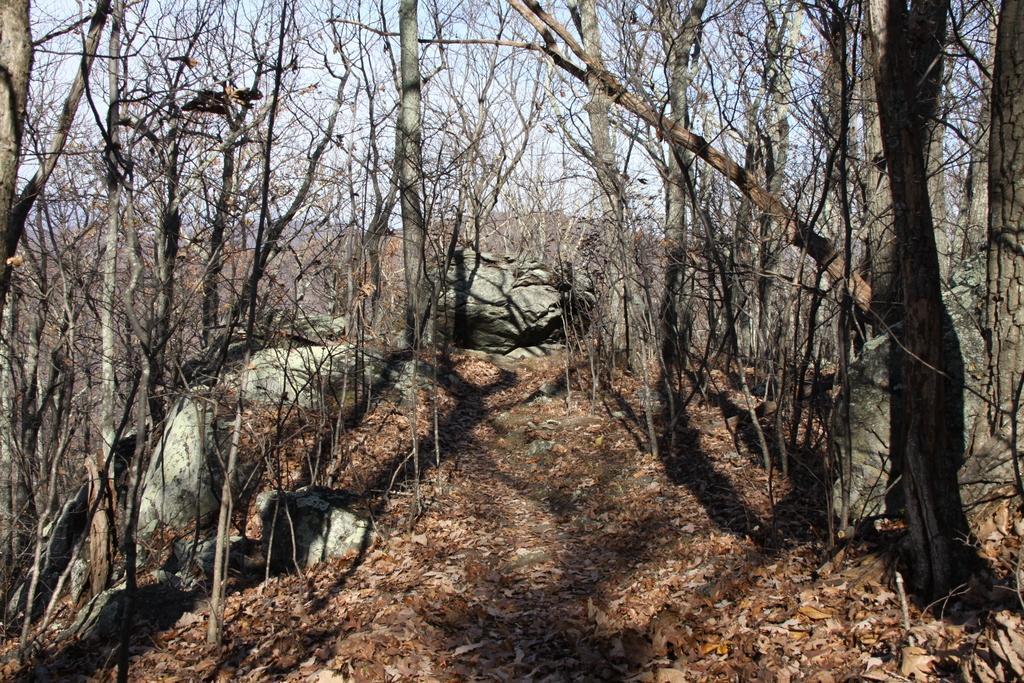In one or two sentences, can you explain what this image depicts? In this image we can see some trees and rocks. In the background of the image there is the sky and mountains. At the bottom of the image there are dry leaves and a walkway. 